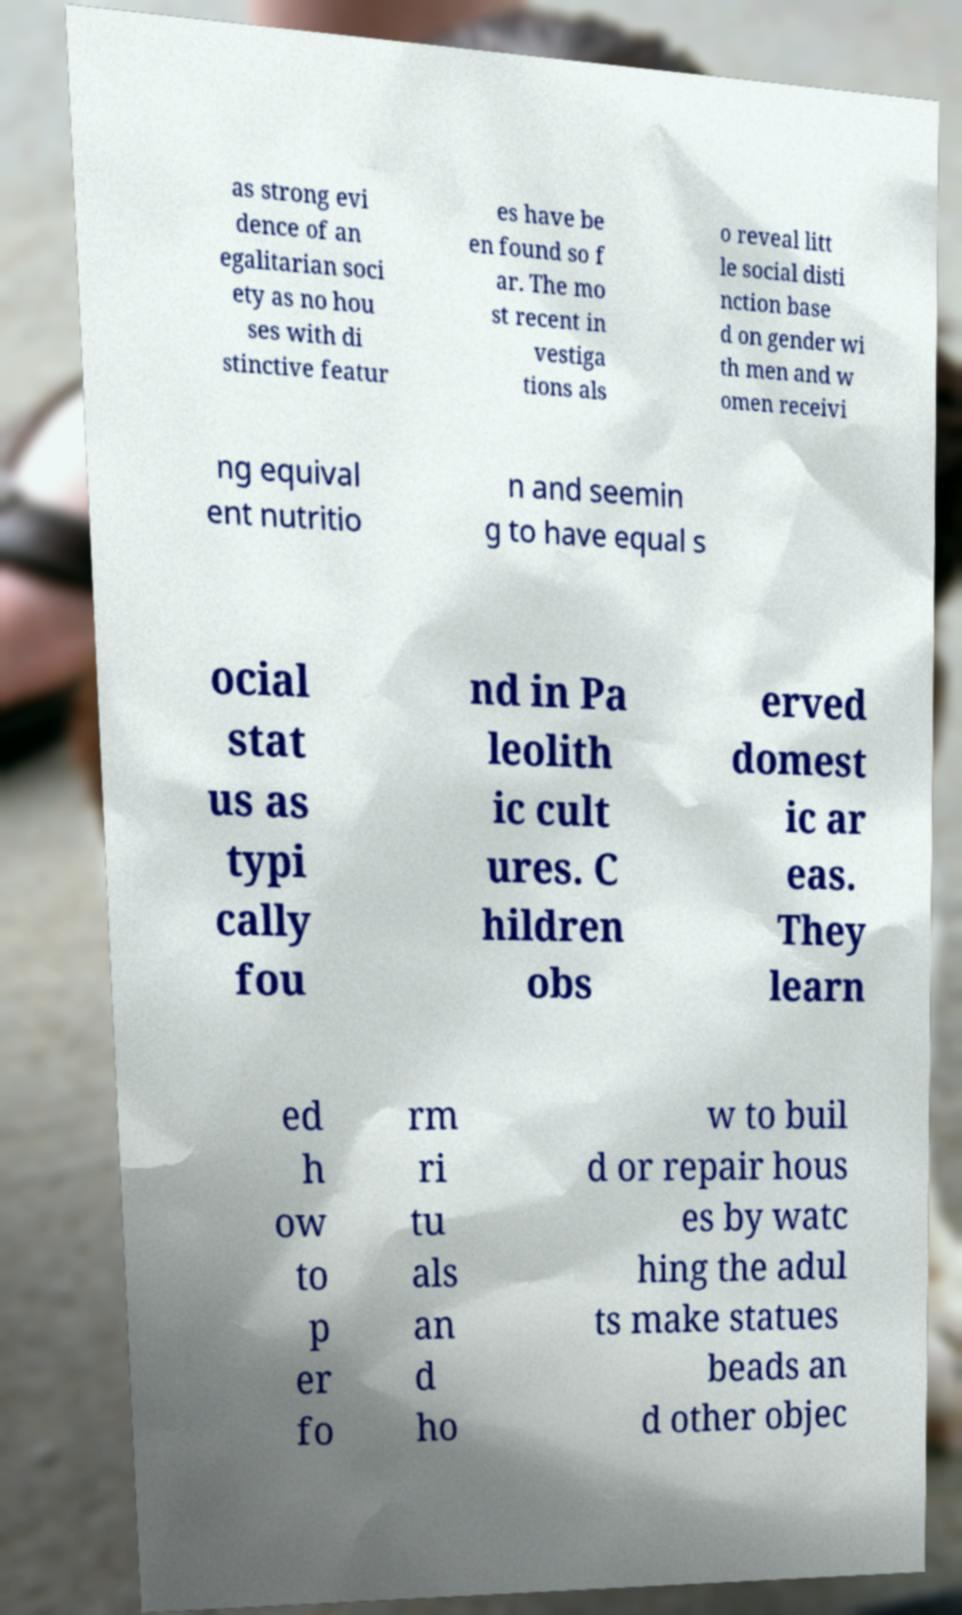Please identify and transcribe the text found in this image. as strong evi dence of an egalitarian soci ety as no hou ses with di stinctive featur es have be en found so f ar. The mo st recent in vestiga tions als o reveal litt le social disti nction base d on gender wi th men and w omen receivi ng equival ent nutritio n and seemin g to have equal s ocial stat us as typi cally fou nd in Pa leolith ic cult ures. C hildren obs erved domest ic ar eas. They learn ed h ow to p er fo rm ri tu als an d ho w to buil d or repair hous es by watc hing the adul ts make statues beads an d other objec 